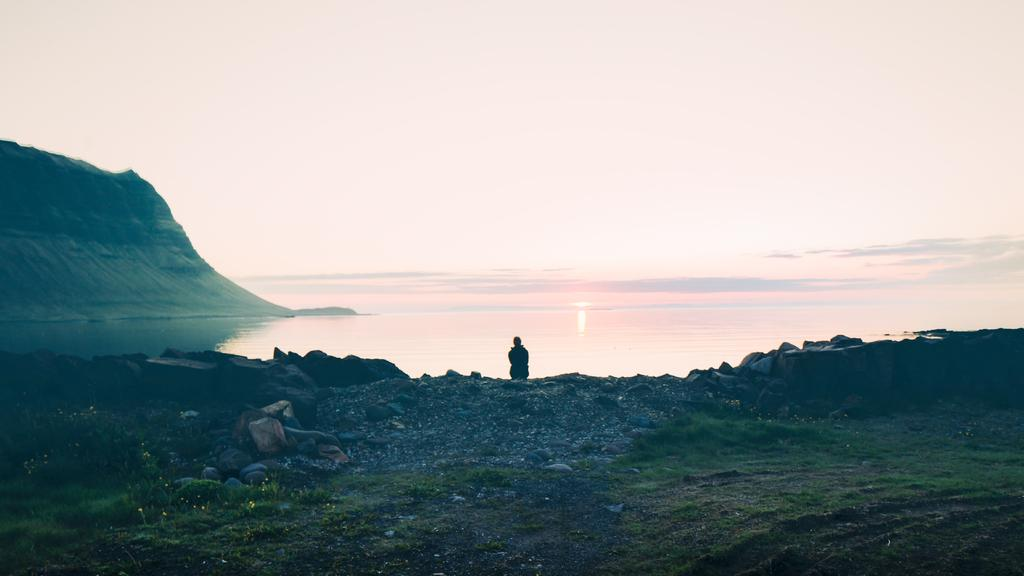Who or what is present in the image? There is a person in the image. What type of terrain is visible in the image? There is grass, rocks, water, and a hill in the image. What can be seen in the background of the image? The sun and sky are visible in the background. What type of potato is being harvested by the farmer in the image? There is no farmer or potato present in the image. Can you see a bike in the image? There is no bike present in the image. 